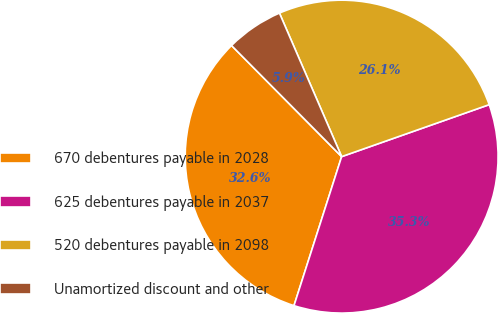Convert chart to OTSL. <chart><loc_0><loc_0><loc_500><loc_500><pie_chart><fcel>670 debentures payable in 2028<fcel>625 debentures payable in 2037<fcel>520 debentures payable in 2098<fcel>Unamortized discount and other<nl><fcel>32.65%<fcel>35.32%<fcel>26.12%<fcel>5.92%<nl></chart> 